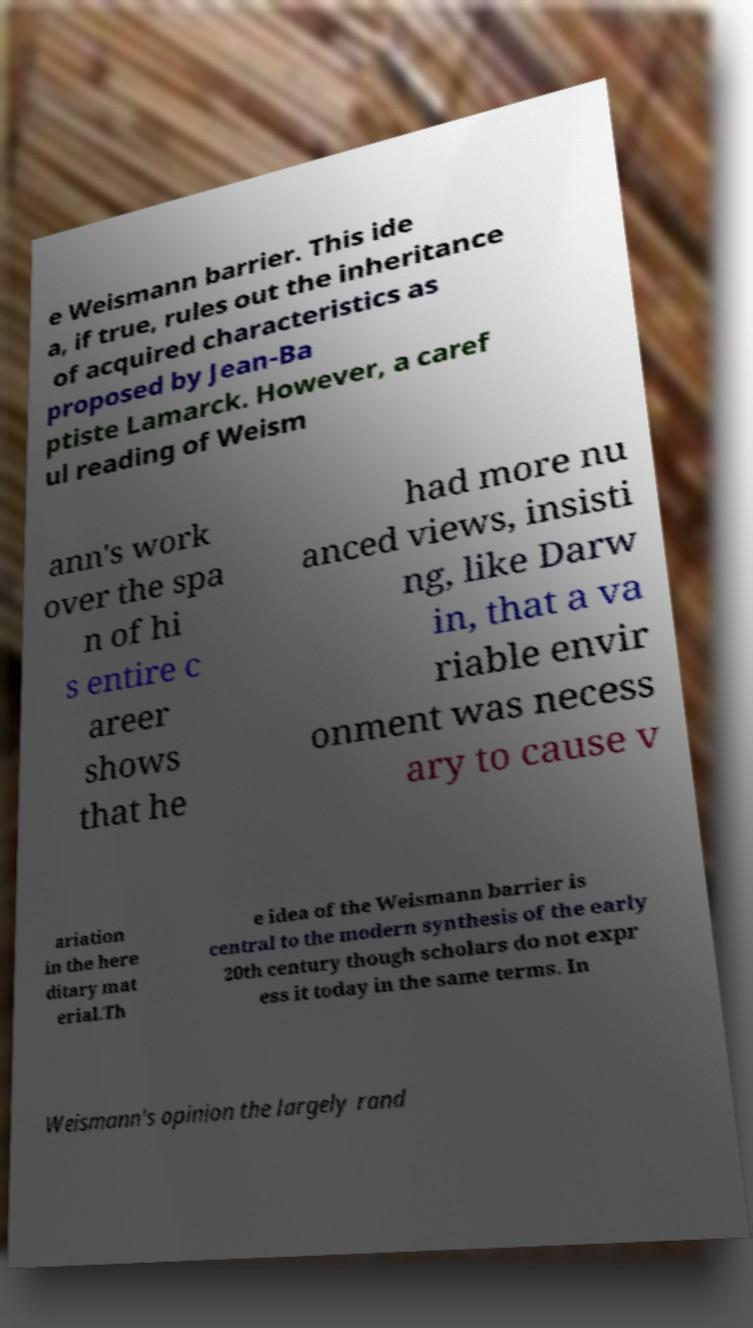Can you accurately transcribe the text from the provided image for me? e Weismann barrier. This ide a, if true, rules out the inheritance of acquired characteristics as proposed by Jean-Ba ptiste Lamarck. However, a caref ul reading of Weism ann's work over the spa n of hi s entire c areer shows that he had more nu anced views, insisti ng, like Darw in, that a va riable envir onment was necess ary to cause v ariation in the here ditary mat erial.Th e idea of the Weismann barrier is central to the modern synthesis of the early 20th century though scholars do not expr ess it today in the same terms. In Weismann's opinion the largely rand 